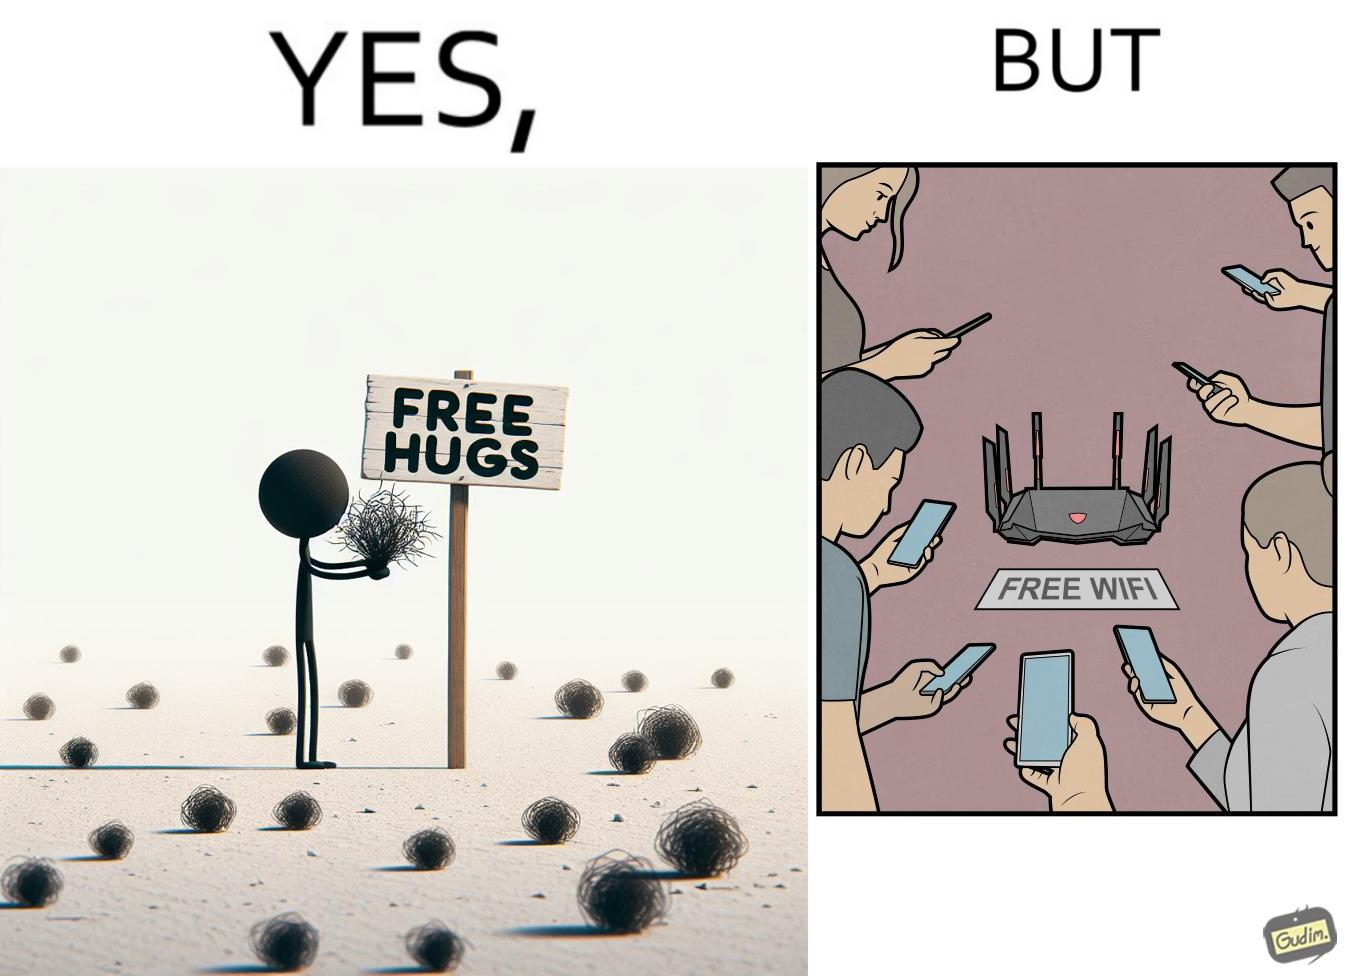What do you see in each half of this image? In the left part of the image: a person standing alone holding a sign "Free Hugs". The tumbleweeds blowing in the wind further stress on the loneliness. In the right part of the image: A Wi-fi Router with the label "Free Wifi" in front of it, surrounded by people trying to connect to it on their mobile devices. 